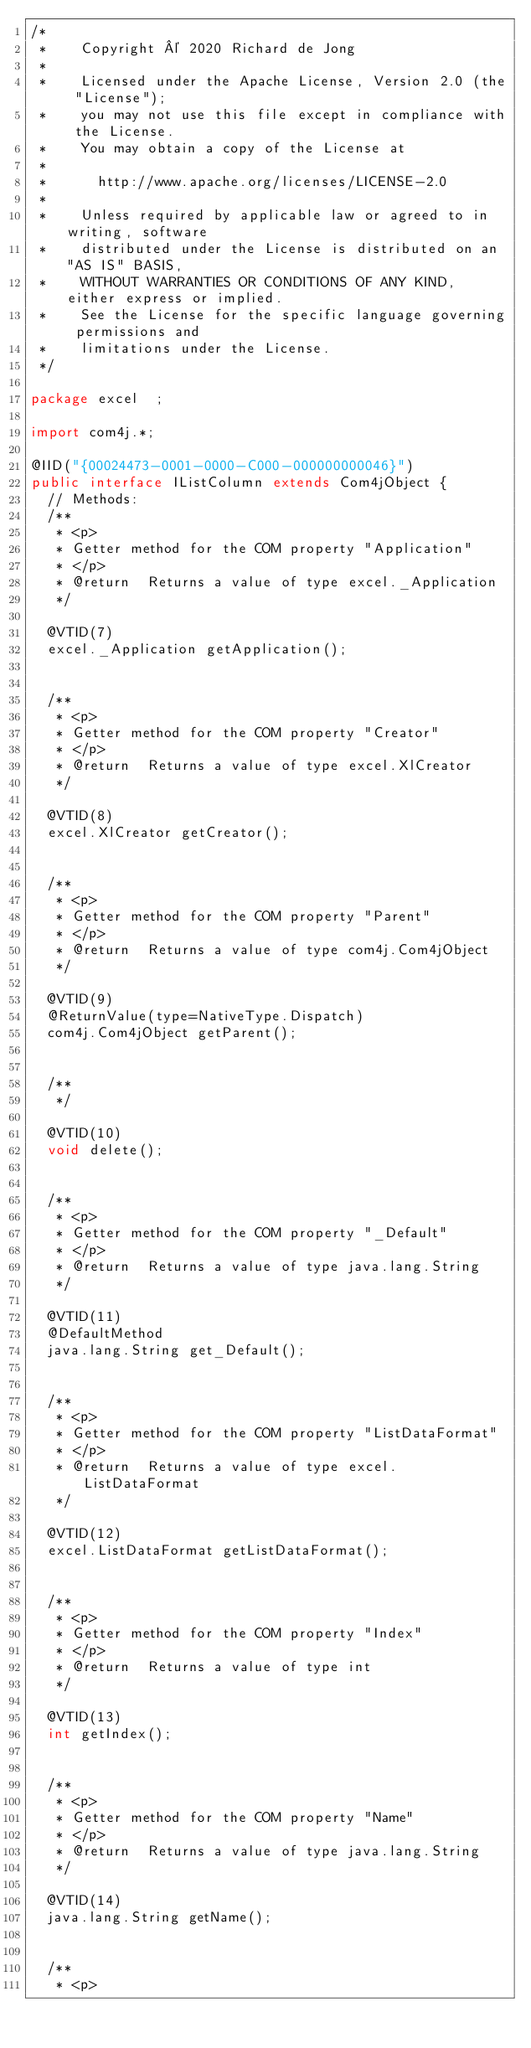Convert code to text. <code><loc_0><loc_0><loc_500><loc_500><_Java_>/*
 *    Copyright © 2020 Richard de Jong
 *
 *    Licensed under the Apache License, Version 2.0 (the "License");
 *    you may not use this file except in compliance with the License.
 *    You may obtain a copy of the License at
 *
 *      http://www.apache.org/licenses/LICENSE-2.0
 *
 *    Unless required by applicable law or agreed to in writing, software
 *    distributed under the License is distributed on an "AS IS" BASIS,
 *    WITHOUT WARRANTIES OR CONDITIONS OF ANY KIND, either express or implied.
 *    See the License for the specific language governing permissions and
 *    limitations under the License.
 */

package excel  ;

import com4j.*;

@IID("{00024473-0001-0000-C000-000000000046}")
public interface IListColumn extends Com4jObject {
  // Methods:
  /**
   * <p>
   * Getter method for the COM property "Application"
   * </p>
   * @return  Returns a value of type excel._Application
   */

  @VTID(7)
  excel._Application getApplication();


  /**
   * <p>
   * Getter method for the COM property "Creator"
   * </p>
   * @return  Returns a value of type excel.XlCreator
   */

  @VTID(8)
  excel.XlCreator getCreator();


  /**
   * <p>
   * Getter method for the COM property "Parent"
   * </p>
   * @return  Returns a value of type com4j.Com4jObject
   */

  @VTID(9)
  @ReturnValue(type=NativeType.Dispatch)
  com4j.Com4jObject getParent();


  /**
   */

  @VTID(10)
  void delete();


  /**
   * <p>
   * Getter method for the COM property "_Default"
   * </p>
   * @return  Returns a value of type java.lang.String
   */

  @VTID(11)
  @DefaultMethod
  java.lang.String get_Default();


  /**
   * <p>
   * Getter method for the COM property "ListDataFormat"
   * </p>
   * @return  Returns a value of type excel.ListDataFormat
   */

  @VTID(12)
  excel.ListDataFormat getListDataFormat();


  /**
   * <p>
   * Getter method for the COM property "Index"
   * </p>
   * @return  Returns a value of type int
   */

  @VTID(13)
  int getIndex();


  /**
   * <p>
   * Getter method for the COM property "Name"
   * </p>
   * @return  Returns a value of type java.lang.String
   */

  @VTID(14)
  java.lang.String getName();


  /**
   * <p></code> 